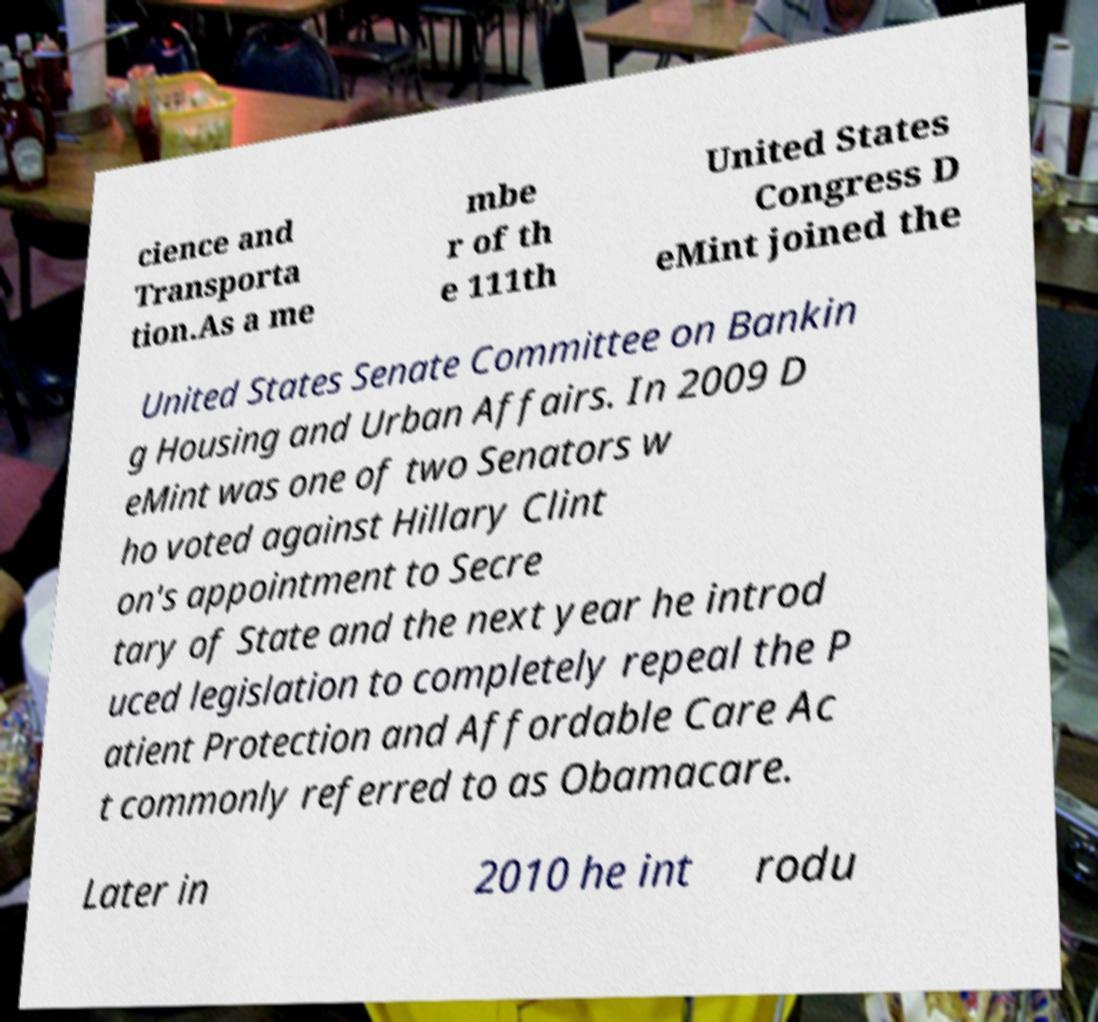Can you accurately transcribe the text from the provided image for me? cience and Transporta tion.As a me mbe r of th e 111th United States Congress D eMint joined the United States Senate Committee on Bankin g Housing and Urban Affairs. In 2009 D eMint was one of two Senators w ho voted against Hillary Clint on's appointment to Secre tary of State and the next year he introd uced legislation to completely repeal the P atient Protection and Affordable Care Ac t commonly referred to as Obamacare. Later in 2010 he int rodu 